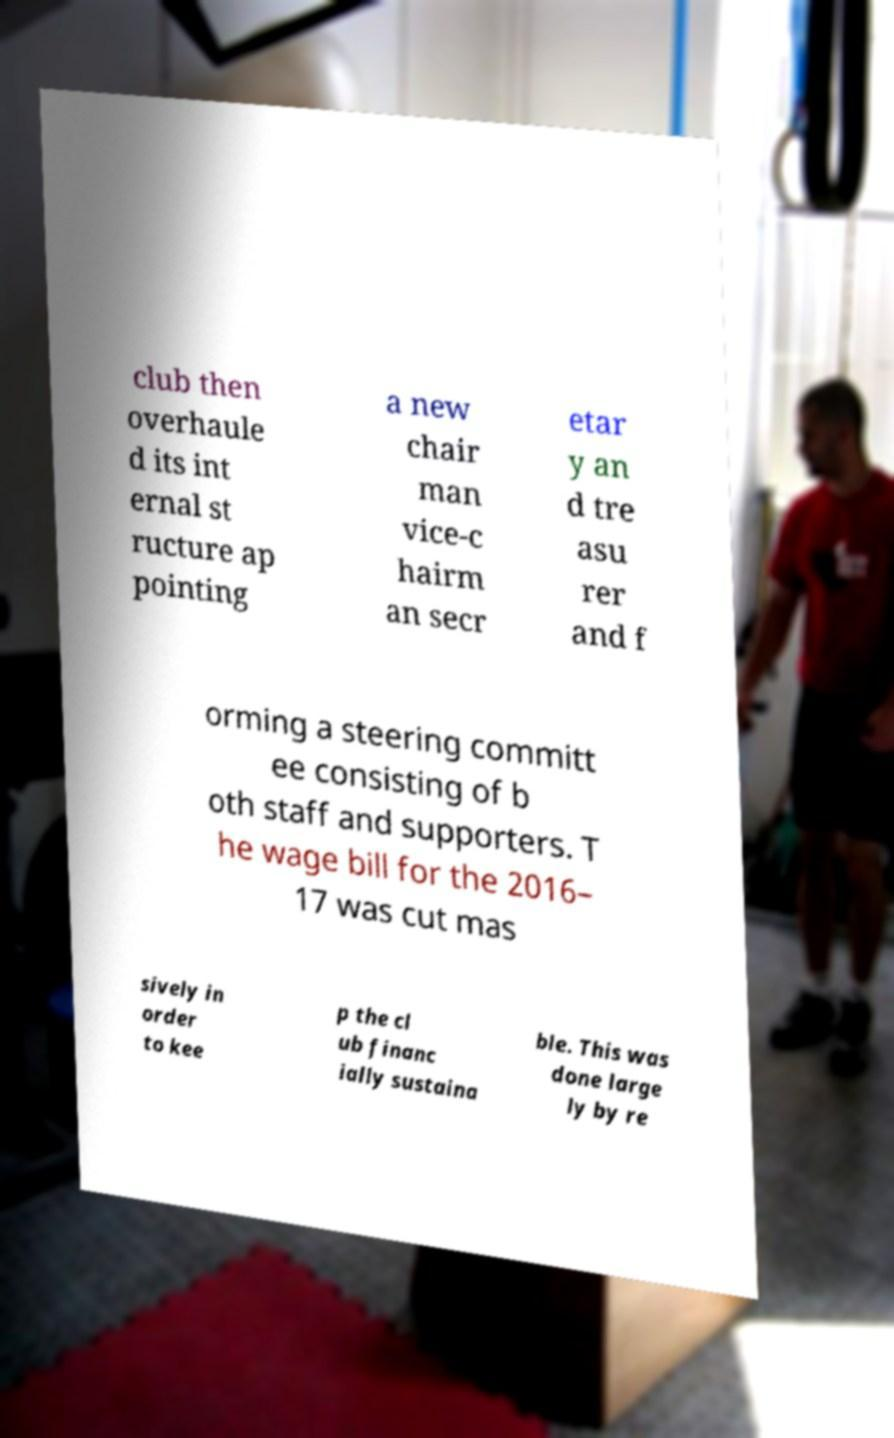Please identify and transcribe the text found in this image. club then overhaule d its int ernal st ructure ap pointing a new chair man vice-c hairm an secr etar y an d tre asu rer and f orming a steering committ ee consisting of b oth staff and supporters. T he wage bill for the 2016– 17 was cut mas sively in order to kee p the cl ub financ ially sustaina ble. This was done large ly by re 